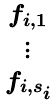<formula> <loc_0><loc_0><loc_500><loc_500>\begin{smallmatrix} f _ { i , 1 } \\ \vdots \\ \\ f _ { i , s _ { i } } \end{smallmatrix}</formula> 